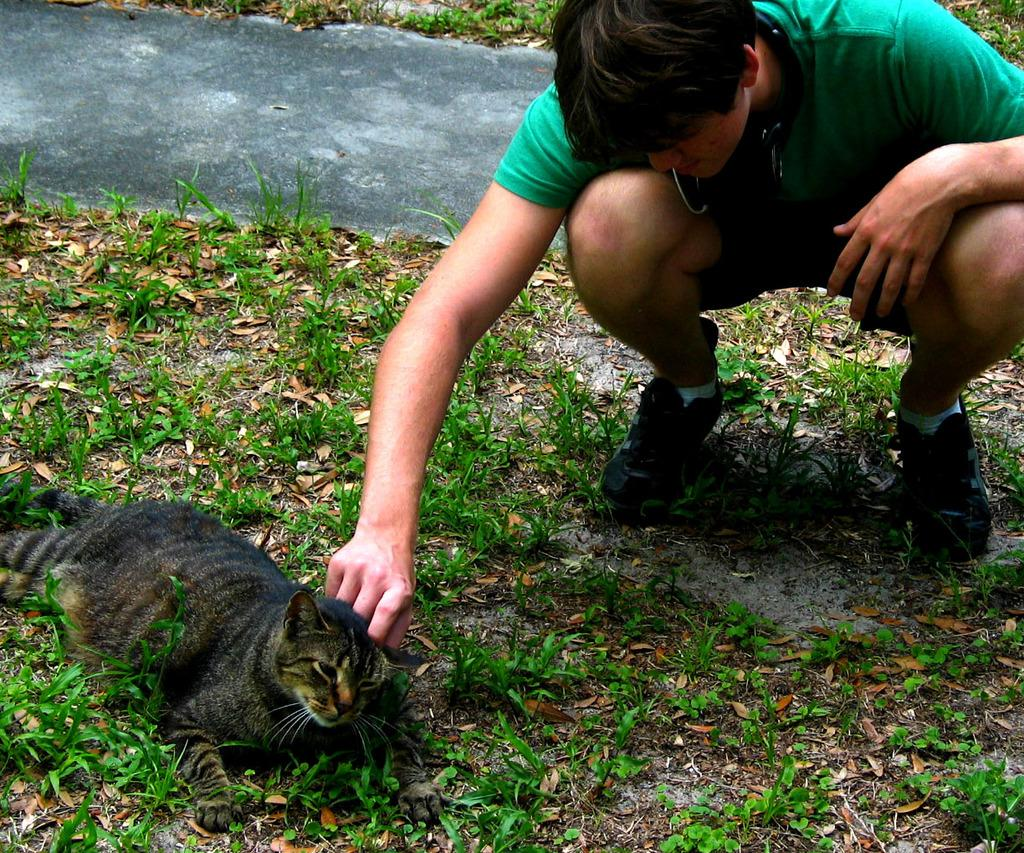What type of animal is in the image? There is a cat in the image. Where is the cat located in the image? The cat is on the grass and located in the bottom left side of the image. Who else is in the image besides the cat? There is a person in the image. What is the person doing in the image? The person is sitting and touching the cat. Where is the person located in the image? The person is located in the top right side of the image. What type of pie is the cat eating in the image? There is no pie present in the image, and the cat is not eating anything. 